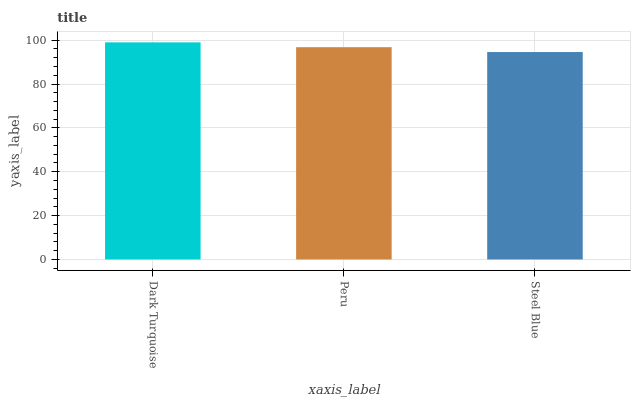Is Steel Blue the minimum?
Answer yes or no. Yes. Is Dark Turquoise the maximum?
Answer yes or no. Yes. Is Peru the minimum?
Answer yes or no. No. Is Peru the maximum?
Answer yes or no. No. Is Dark Turquoise greater than Peru?
Answer yes or no. Yes. Is Peru less than Dark Turquoise?
Answer yes or no. Yes. Is Peru greater than Dark Turquoise?
Answer yes or no. No. Is Dark Turquoise less than Peru?
Answer yes or no. No. Is Peru the high median?
Answer yes or no. Yes. Is Peru the low median?
Answer yes or no. Yes. Is Dark Turquoise the high median?
Answer yes or no. No. Is Steel Blue the low median?
Answer yes or no. No. 